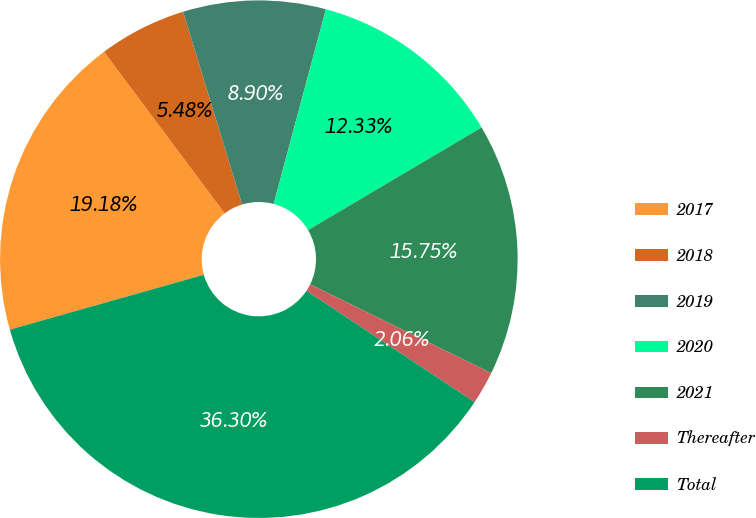<chart> <loc_0><loc_0><loc_500><loc_500><pie_chart><fcel>2017<fcel>2018<fcel>2019<fcel>2020<fcel>2021<fcel>Thereafter<fcel>Total<nl><fcel>19.18%<fcel>5.48%<fcel>8.9%<fcel>12.33%<fcel>15.75%<fcel>2.06%<fcel>36.3%<nl></chart> 